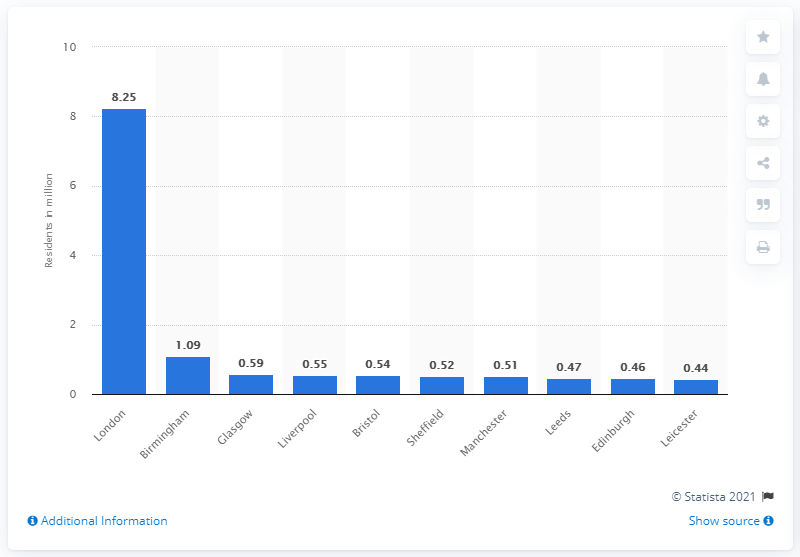Outline some significant characteristics in this image. London is the largest city in the United Kingdom. In 2011, an estimated 8.25 million people resided in London. 